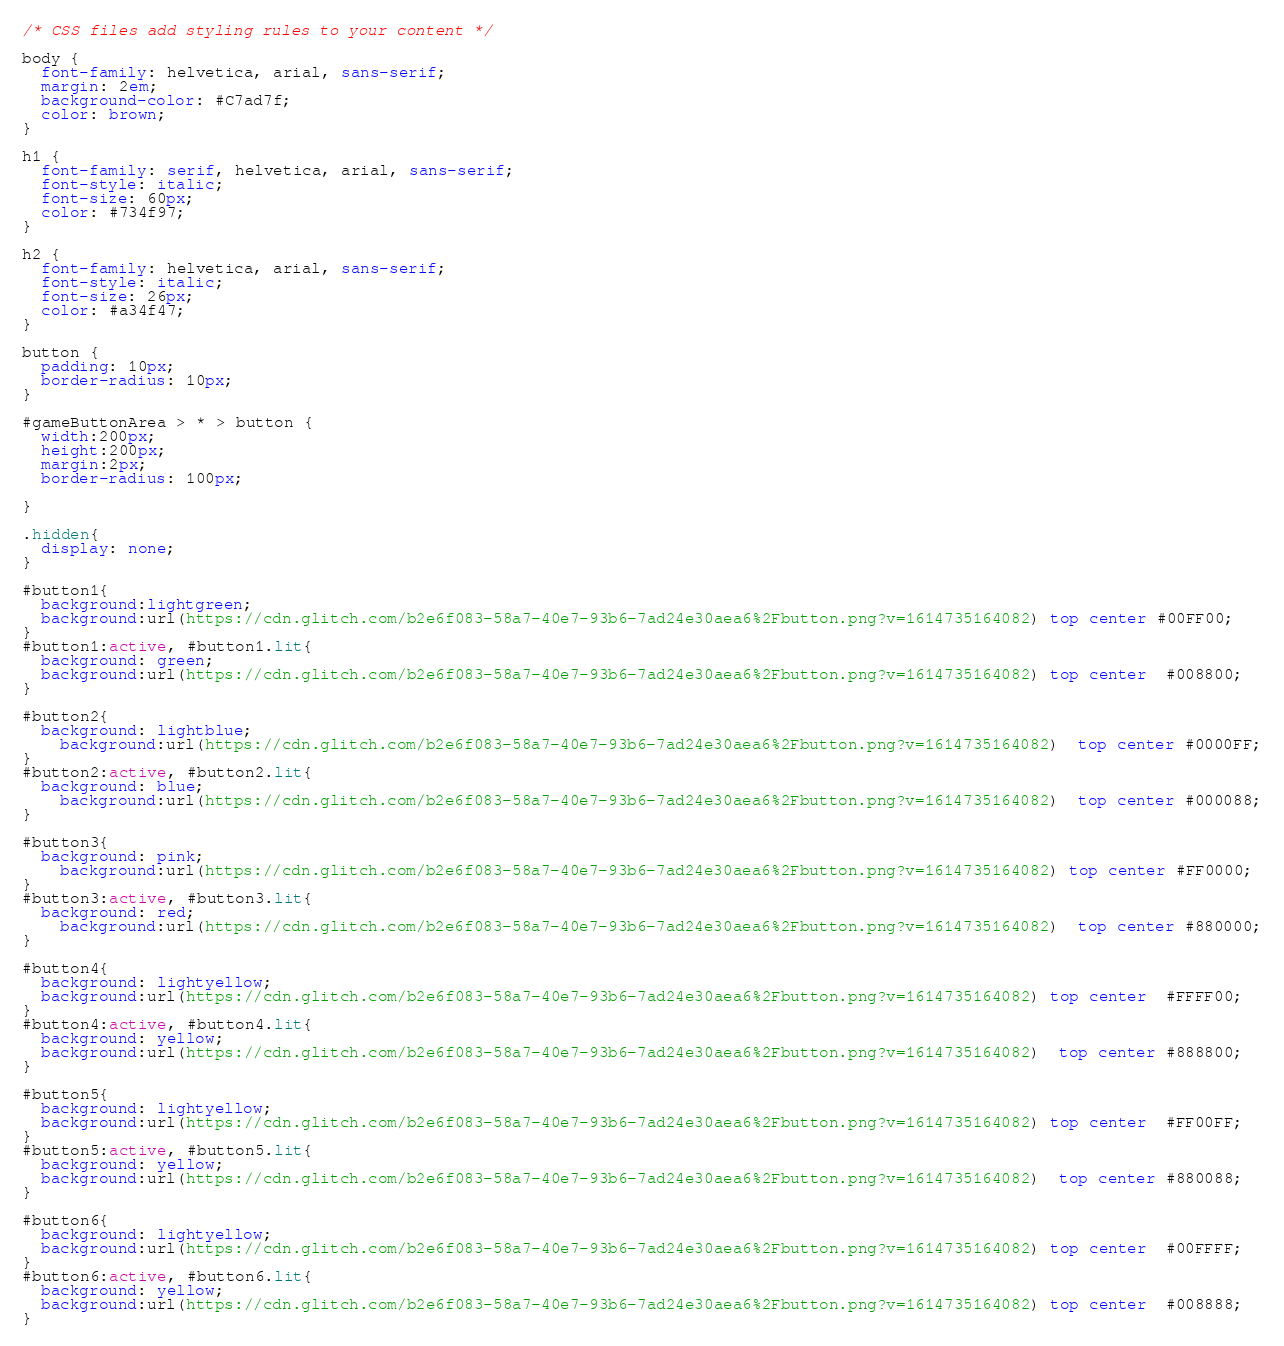Convert code to text. <code><loc_0><loc_0><loc_500><loc_500><_CSS_>/* CSS files add styling rules to your content */

body {
  font-family: helvetica, arial, sans-serif;
  margin: 2em;
  background-color: #C7ad7f;
  color: brown;
}

h1 {
  font-family: serif, helvetica, arial, sans-serif;
  font-style: italic;
  font-size: 60px;
  color: #734f97;
}

h2 {
  font-family: helvetica, arial, sans-serif;
  font-style: italic;
  font-size: 26px;
  color: #a34f47;
}

button {
  padding: 10px;
  border-radius: 10px;
}

#gameButtonArea > * > button {
  width:200px;
  height:200px;
  margin:2px;
  border-radius: 100px;

}

.hidden{
  display: none;
}

#button1{
  background:lightgreen;
  background:url(https://cdn.glitch.com/b2e6f083-58a7-40e7-93b6-7ad24e30aea6%2Fbutton.png?v=1614735164082) top center #00FF00;
}
#button1:active, #button1.lit{
  background: green;
  background:url(https://cdn.glitch.com/b2e6f083-58a7-40e7-93b6-7ad24e30aea6%2Fbutton.png?v=1614735164082) top center  #008800;
}

#button2{
  background: lightblue;
    background:url(https://cdn.glitch.com/b2e6f083-58a7-40e7-93b6-7ad24e30aea6%2Fbutton.png?v=1614735164082)  top center #0000FF;
}
#button2:active, #button2.lit{
  background: blue;
    background:url(https://cdn.glitch.com/b2e6f083-58a7-40e7-93b6-7ad24e30aea6%2Fbutton.png?v=1614735164082)  top center #000088;
}

#button3{
  background: pink;
    background:url(https://cdn.glitch.com/b2e6f083-58a7-40e7-93b6-7ad24e30aea6%2Fbutton.png?v=1614735164082) top center #FF0000;
}
#button3:active, #button3.lit{
  background: red;
    background:url(https://cdn.glitch.com/b2e6f083-58a7-40e7-93b6-7ad24e30aea6%2Fbutton.png?v=1614735164082)  top center #880000;
}

#button4{
  background: lightyellow;
  background:url(https://cdn.glitch.com/b2e6f083-58a7-40e7-93b6-7ad24e30aea6%2Fbutton.png?v=1614735164082) top center  #FFFF00;
}
#button4:active, #button4.lit{
  background: yellow;
  background:url(https://cdn.glitch.com/b2e6f083-58a7-40e7-93b6-7ad24e30aea6%2Fbutton.png?v=1614735164082)  top center #888800;
}

#button5{
  background: lightyellow;
  background:url(https://cdn.glitch.com/b2e6f083-58a7-40e7-93b6-7ad24e30aea6%2Fbutton.png?v=1614735164082) top center  #FF00FF;
}
#button5:active, #button5.lit{
  background: yellow;
  background:url(https://cdn.glitch.com/b2e6f083-58a7-40e7-93b6-7ad24e30aea6%2Fbutton.png?v=1614735164082)  top center #880088;
}

#button6{
  background: lightyellow;
  background:url(https://cdn.glitch.com/b2e6f083-58a7-40e7-93b6-7ad24e30aea6%2Fbutton.png?v=1614735164082) top center  #00FFFF;
}
#button6:active, #button6.lit{
  background: yellow;
  background:url(https://cdn.glitch.com/b2e6f083-58a7-40e7-93b6-7ad24e30aea6%2Fbutton.png?v=1614735164082) top center  #008888;
}</code> 